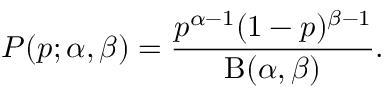<formula> <loc_0><loc_0><loc_500><loc_500>P ( p ; \alpha , \beta ) = { \frac { p ^ { \alpha - 1 } ( 1 - p ) ^ { \beta - 1 } } { B ( \alpha , \beta ) } } .</formula> 